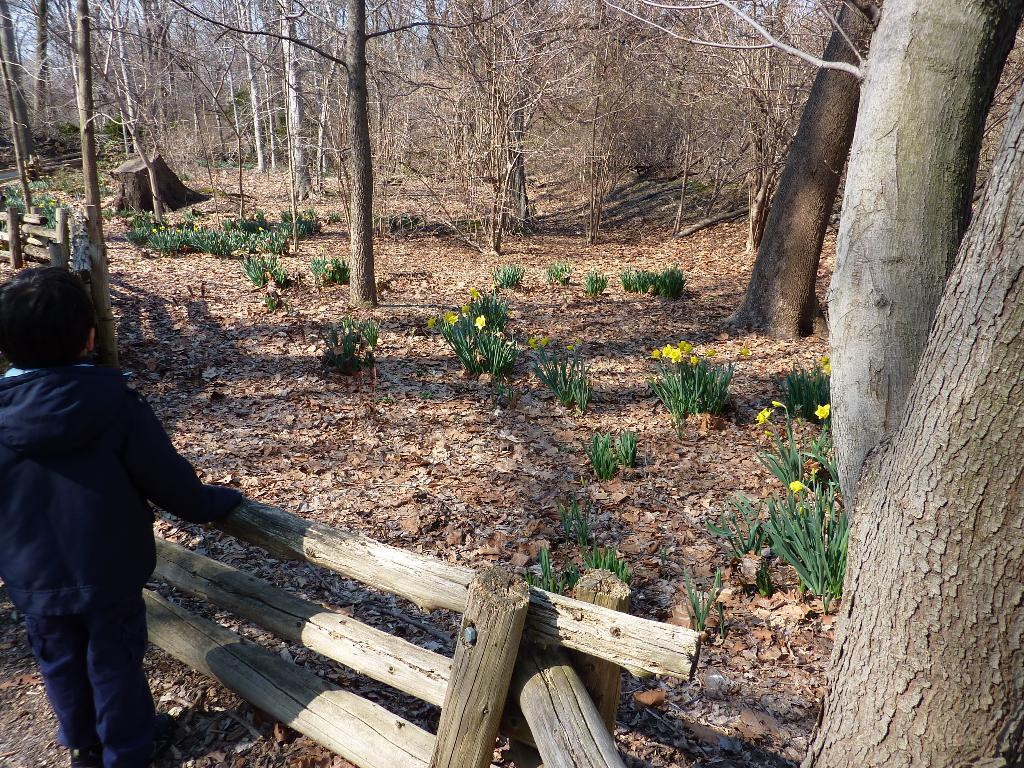Where is the boy located in the image? The boy is standing in the left bottom of the image. What is in front of the boy? There is wooden fencing in front of the boy. What can be seen in the background of the image? Trees are present in the background of the image. What type of vegetation is visible on the land in the image? Plants are visible on the land in the image. What else can be seen on the land in the image? Dry leaves are present on the land in the image. What type of zephyr can be seen blowing through the ship in the image? There is no ship present in the image, and therefore no zephyr can be seen blowing through it. 